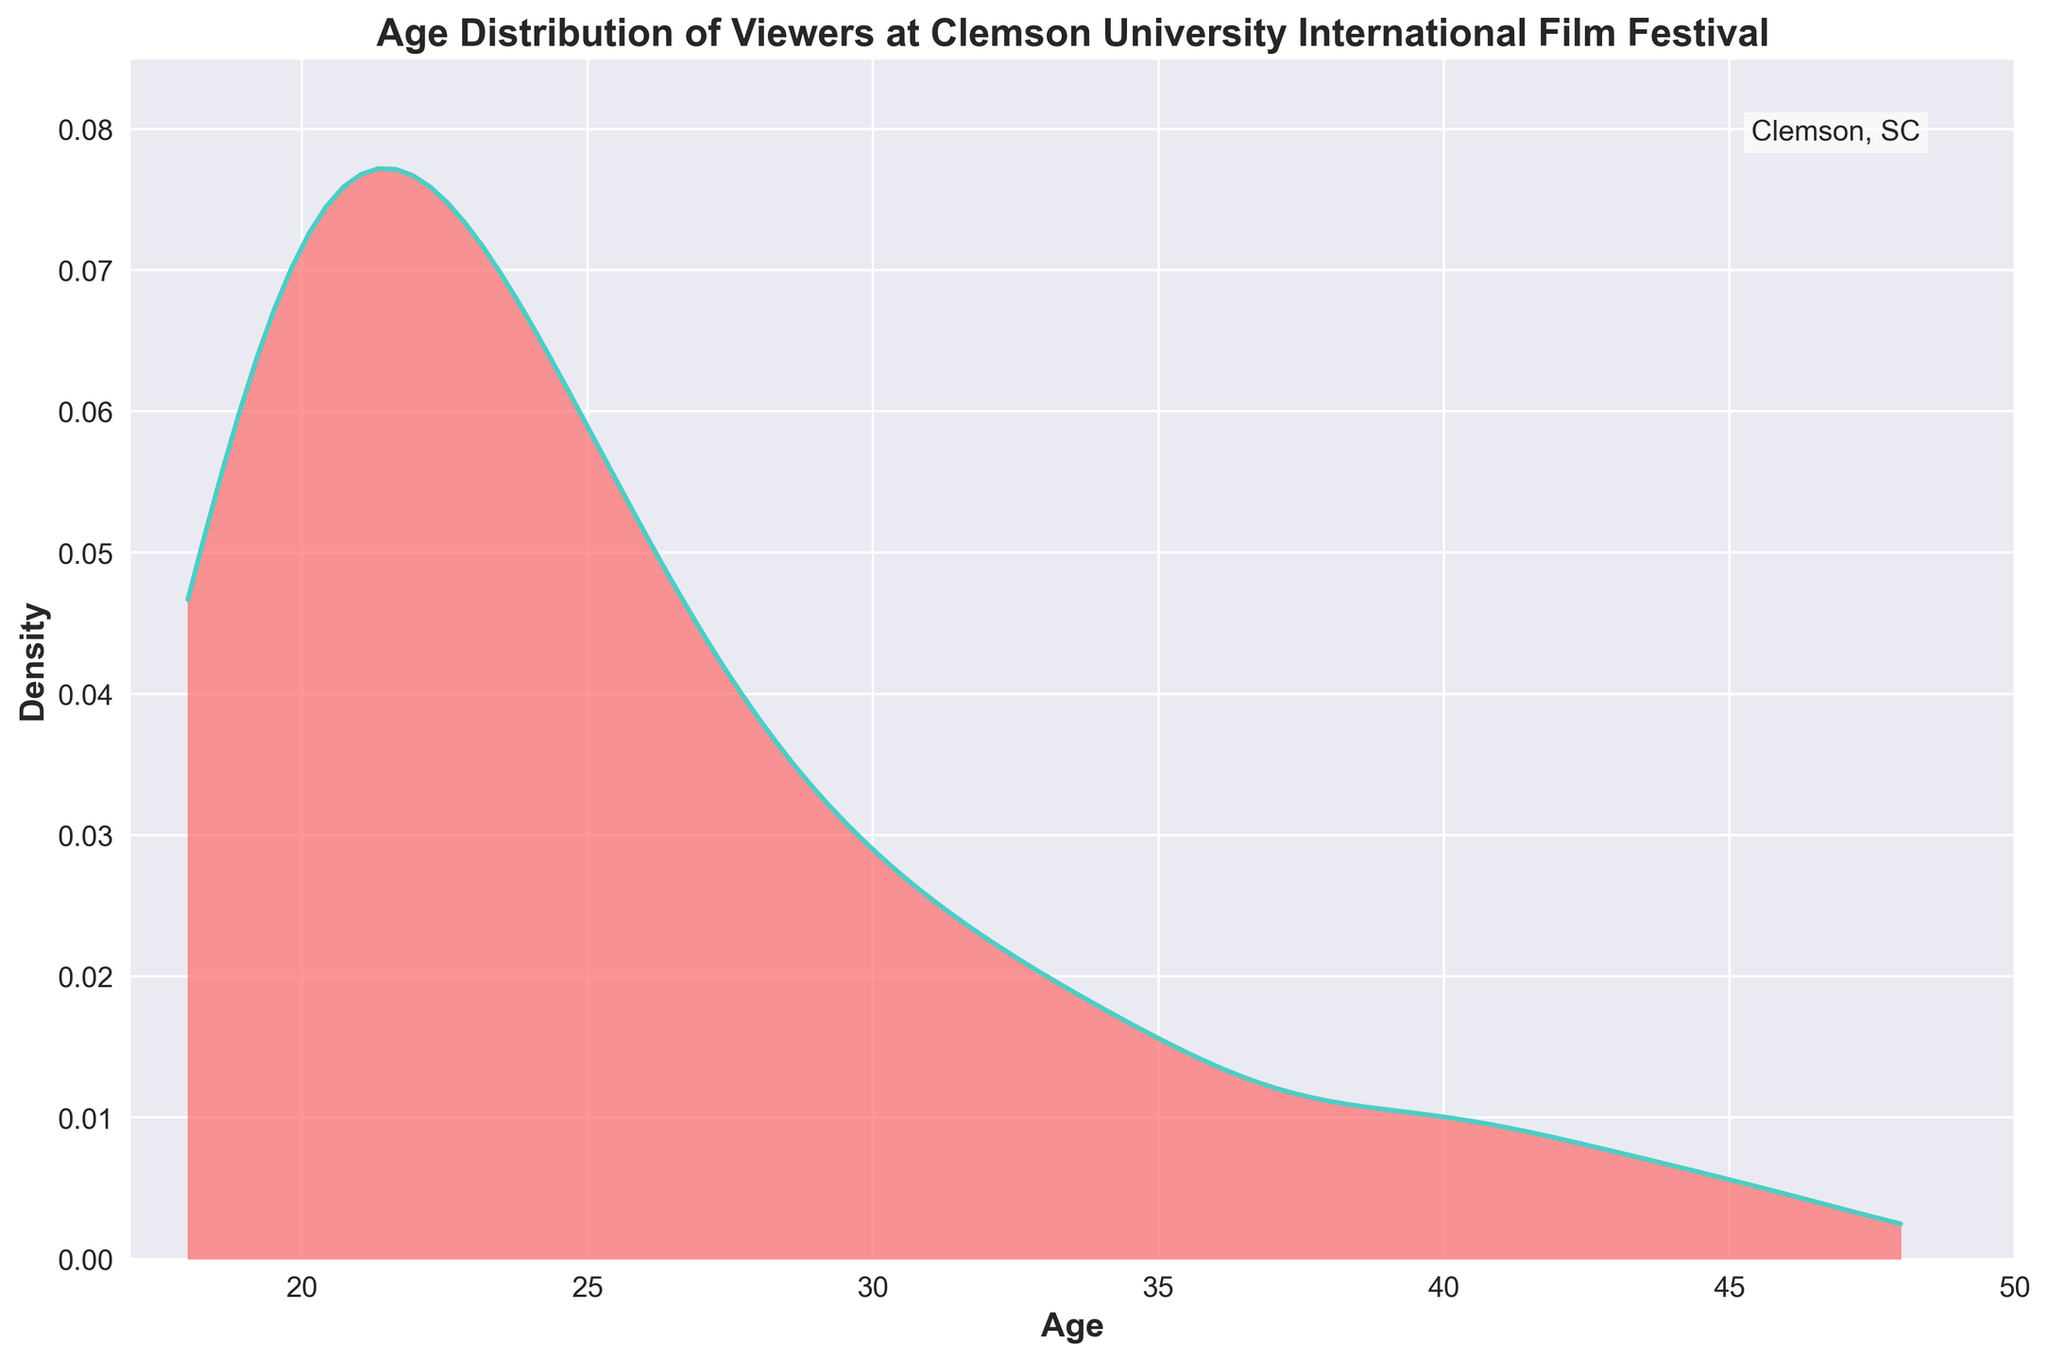What is the title of the plot? The title of the plot is displayed prominently at the top and it reads "Age Distribution of Viewers at Clemson University International Film Festival".
Answer: Age Distribution of Viewers at Clemson University International Film Festival What are the x-axis and y-axis labels? The x-axis label reads "Age" and the y-axis label reads "Density".
Answer: Age; Density What color is used for the filled area under the curve? The filled area under the curve is colored in a shade of red.
Answer: Red Where does the density peak occur? The peak of the density curve can be observed around the ages of 21.
Answer: Around age 21 Which age group has the lower density, 25 or 30? The density curve at age 25 is higher than at age 30, indicating that the density for age 30 is lower.
Answer: Age 30 Which age marks the end of the x-axis range? The x-axis ends at age 50.
Answer: Age 50 What is the general trend in viewer age distribution after age 25? After age 25, the density curve shows a decreasing trend, indicating a drop in the number of viewers as age increases.
Answer: Decreasing trend By looking at the density pattern, which age range seems to have the most viewers? The highest density peak around age 21 suggests that the most viewers fall within the age range of approximately 18 to 24.
Answer: 18 to 24 If you had to estimate, at which age does the density fall to near zero? Looking at the curve, the density falls to near zero around age 37 and beyond.
Answer: Around age 37 Does any age group above 40 have a significant density peak? The density curve for age groups above 40 is almost flat and very low, indicating no significant density peaks.
Answer: No 